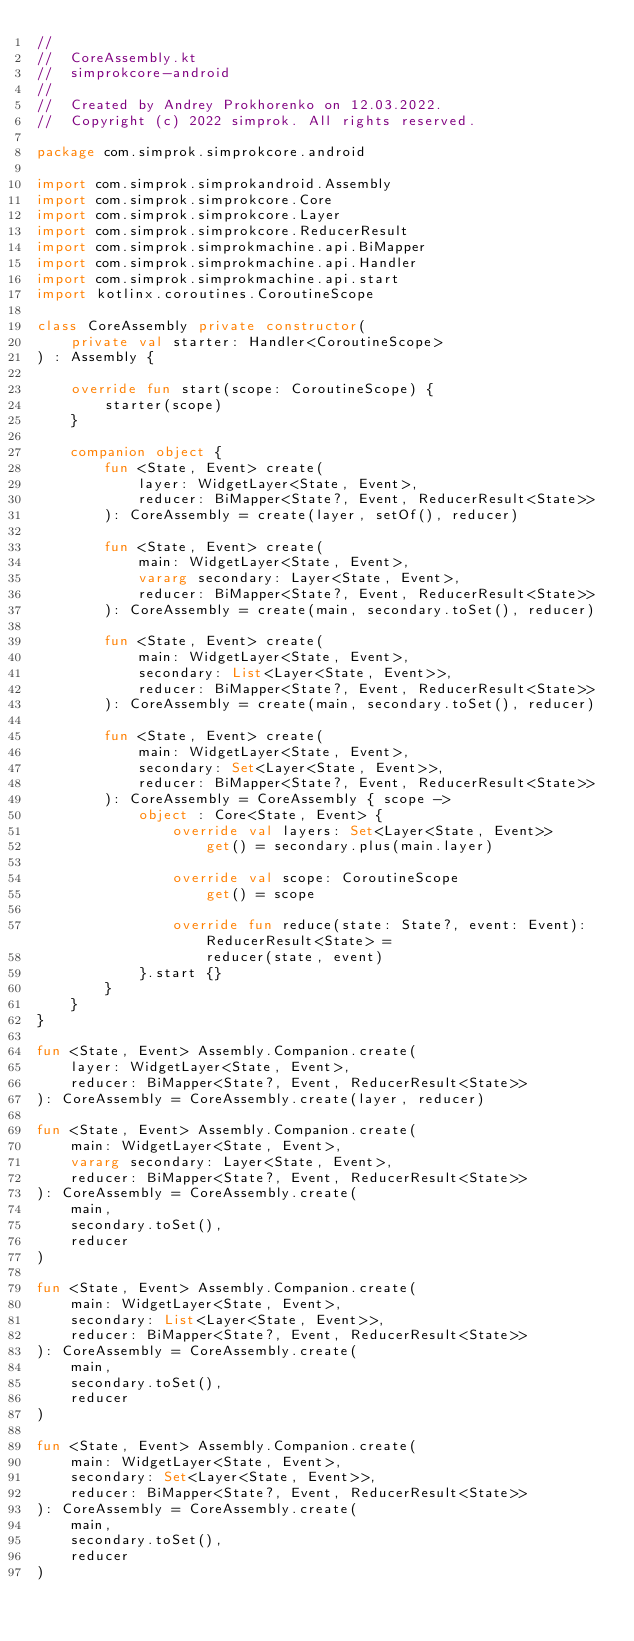<code> <loc_0><loc_0><loc_500><loc_500><_Kotlin_>//
//  CoreAssembly.kt
//  simprokcore-android
//
//  Created by Andrey Prokhorenko on 12.03.2022.
//  Copyright (c) 2022 simprok. All rights reserved.

package com.simprok.simprokcore.android

import com.simprok.simprokandroid.Assembly
import com.simprok.simprokcore.Core
import com.simprok.simprokcore.Layer
import com.simprok.simprokcore.ReducerResult
import com.simprok.simprokmachine.api.BiMapper
import com.simprok.simprokmachine.api.Handler
import com.simprok.simprokmachine.api.start
import kotlinx.coroutines.CoroutineScope

class CoreAssembly private constructor(
    private val starter: Handler<CoroutineScope>
) : Assembly {

    override fun start(scope: CoroutineScope) {
        starter(scope)
    }

    companion object {
        fun <State, Event> create(
            layer: WidgetLayer<State, Event>,
            reducer: BiMapper<State?, Event, ReducerResult<State>>
        ): CoreAssembly = create(layer, setOf(), reducer)

        fun <State, Event> create(
            main: WidgetLayer<State, Event>,
            vararg secondary: Layer<State, Event>,
            reducer: BiMapper<State?, Event, ReducerResult<State>>
        ): CoreAssembly = create(main, secondary.toSet(), reducer)

        fun <State, Event> create(
            main: WidgetLayer<State, Event>,
            secondary: List<Layer<State, Event>>,
            reducer: BiMapper<State?, Event, ReducerResult<State>>
        ): CoreAssembly = create(main, secondary.toSet(), reducer)

        fun <State, Event> create(
            main: WidgetLayer<State, Event>,
            secondary: Set<Layer<State, Event>>,
            reducer: BiMapper<State?, Event, ReducerResult<State>>
        ): CoreAssembly = CoreAssembly { scope ->
            object : Core<State, Event> {
                override val layers: Set<Layer<State, Event>>
                    get() = secondary.plus(main.layer)

                override val scope: CoroutineScope
                    get() = scope

                override fun reduce(state: State?, event: Event): ReducerResult<State> =
                    reducer(state, event)
            }.start {}
        }
    }
}

fun <State, Event> Assembly.Companion.create(
    layer: WidgetLayer<State, Event>,
    reducer: BiMapper<State?, Event, ReducerResult<State>>
): CoreAssembly = CoreAssembly.create(layer, reducer)

fun <State, Event> Assembly.Companion.create(
    main: WidgetLayer<State, Event>,
    vararg secondary: Layer<State, Event>,
    reducer: BiMapper<State?, Event, ReducerResult<State>>
): CoreAssembly = CoreAssembly.create(
    main,
    secondary.toSet(),
    reducer
)

fun <State, Event> Assembly.Companion.create(
    main: WidgetLayer<State, Event>,
    secondary: List<Layer<State, Event>>,
    reducer: BiMapper<State?, Event, ReducerResult<State>>
): CoreAssembly = CoreAssembly.create(
    main,
    secondary.toSet(),
    reducer
)

fun <State, Event> Assembly.Companion.create(
    main: WidgetLayer<State, Event>,
    secondary: Set<Layer<State, Event>>,
    reducer: BiMapper<State?, Event, ReducerResult<State>>
): CoreAssembly = CoreAssembly.create(
    main,
    secondary.toSet(),
    reducer
)</code> 